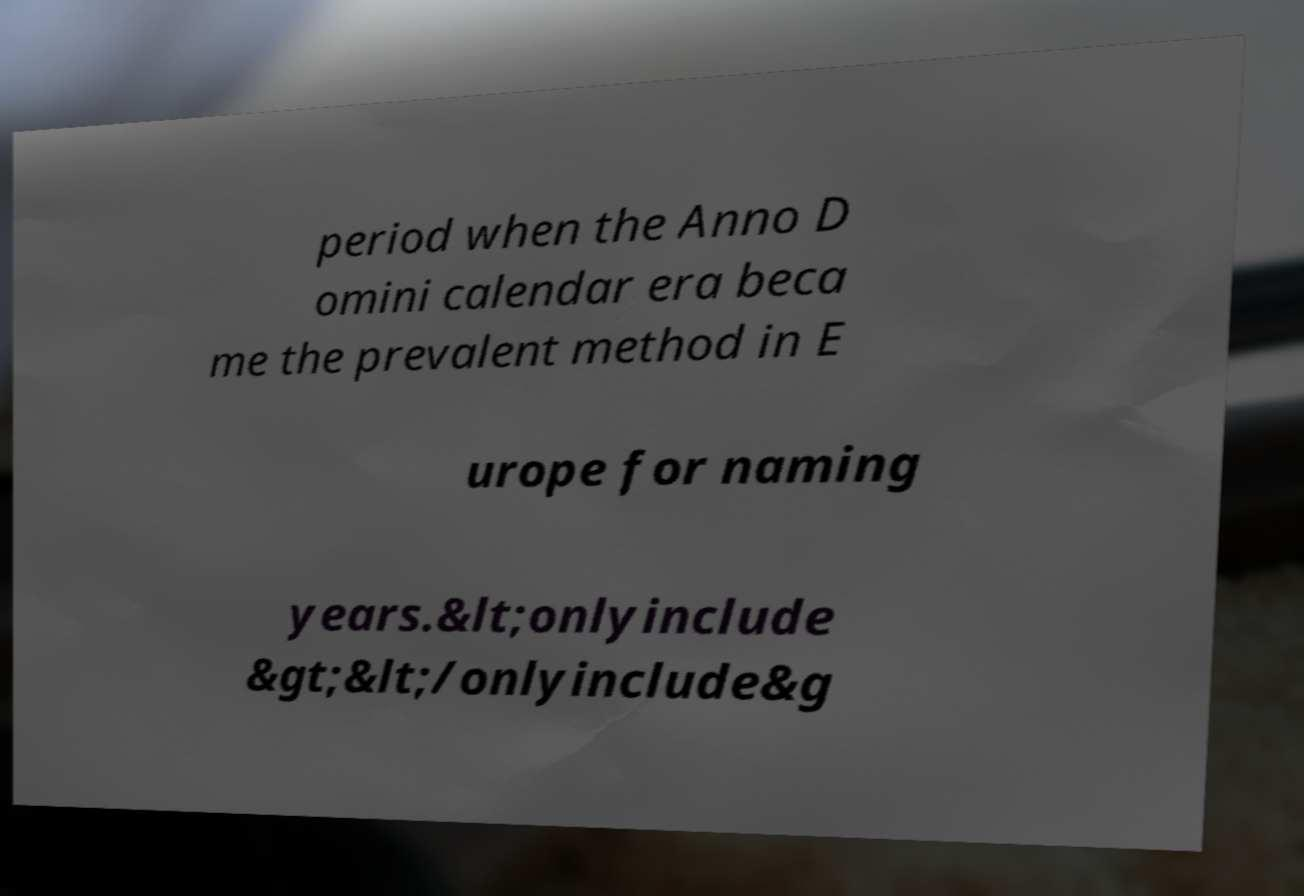Can you read and provide the text displayed in the image?This photo seems to have some interesting text. Can you extract and type it out for me? period when the Anno D omini calendar era beca me the prevalent method in E urope for naming years.&lt;onlyinclude &gt;&lt;/onlyinclude&g 